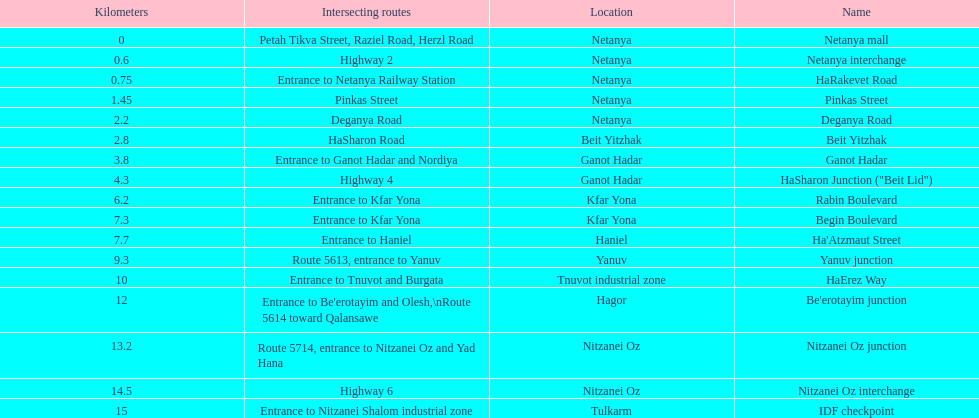Which section is longest?? IDF checkpoint. 